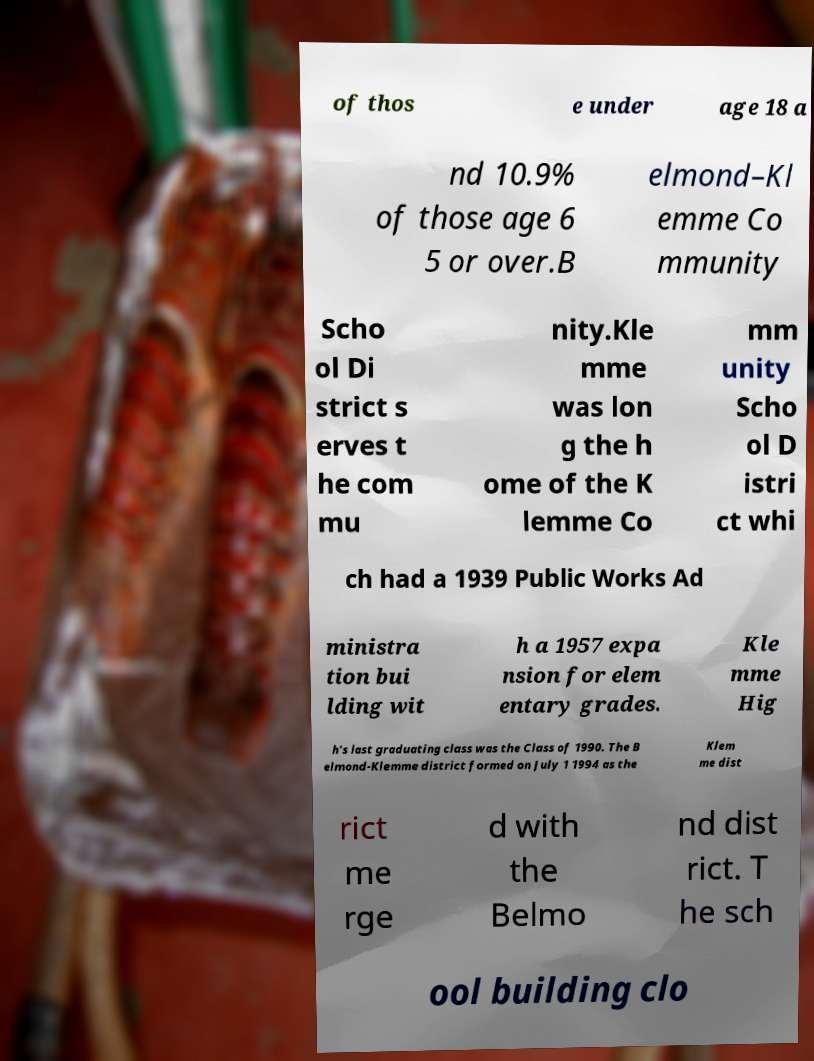I need the written content from this picture converted into text. Can you do that? of thos e under age 18 a nd 10.9% of those age 6 5 or over.B elmond–Kl emme Co mmunity Scho ol Di strict s erves t he com mu nity.Kle mme was lon g the h ome of the K lemme Co mm unity Scho ol D istri ct whi ch had a 1939 Public Works Ad ministra tion bui lding wit h a 1957 expa nsion for elem entary grades. Kle mme Hig h's last graduating class was the Class of 1990. The B elmond-Klemme district formed on July 1 1994 as the Klem me dist rict me rge d with the Belmo nd dist rict. T he sch ool building clo 